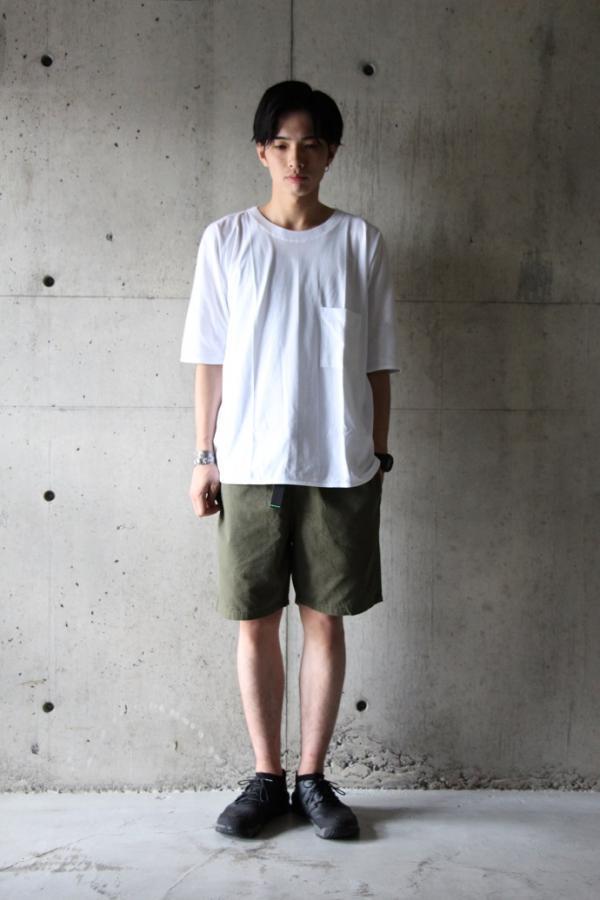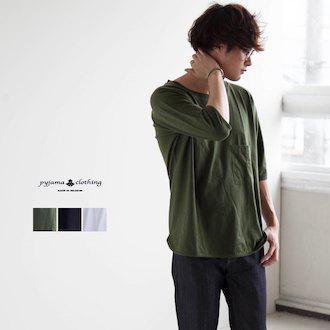The first image is the image on the left, the second image is the image on the right. For the images shown, is this caption "the white t-shirt in the image on the left has a breast pocket" true? Answer yes or no. Yes. 